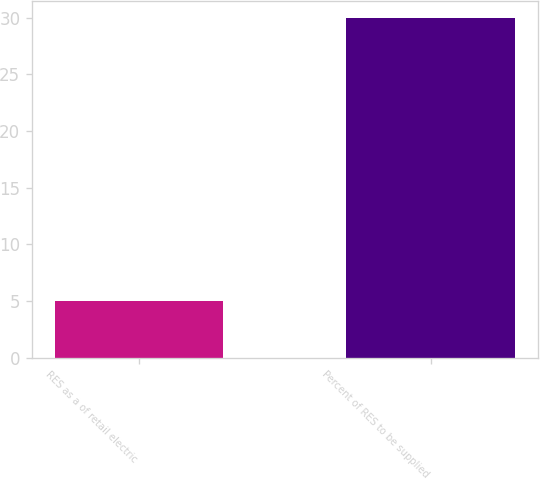Convert chart. <chart><loc_0><loc_0><loc_500><loc_500><bar_chart><fcel>RES as a of retail electric<fcel>Percent of RES to be supplied<nl><fcel>5<fcel>30<nl></chart> 